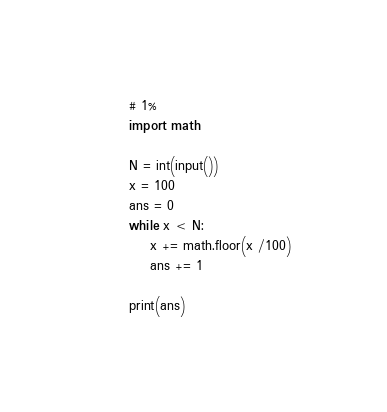<code> <loc_0><loc_0><loc_500><loc_500><_Python_># 1%
import math

N = int(input())
x = 100
ans = 0
while x < N:
    x += math.floor(x /100)
    ans += 1

print(ans)
</code> 